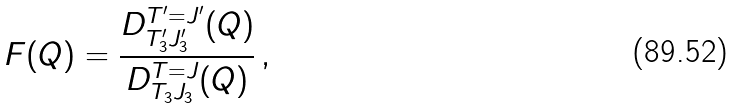<formula> <loc_0><loc_0><loc_500><loc_500>F ( Q ) = \frac { D _ { T _ { 3 } ^ { \prime } J _ { 3 } ^ { \prime } } ^ { T ^ { \prime } = J ^ { \prime } } ( Q ) } { D _ { T _ { 3 } J _ { 3 } } ^ { T = J } ( Q ) } \, ,</formula> 